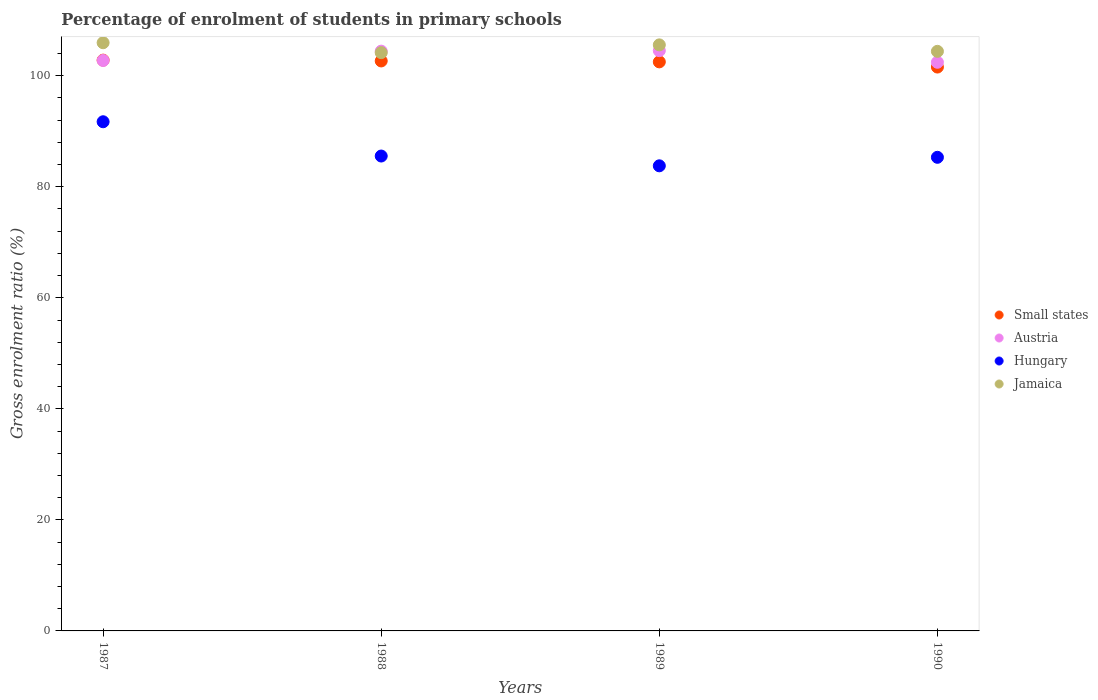How many different coloured dotlines are there?
Provide a succinct answer. 4. What is the percentage of students enrolled in primary schools in Small states in 1988?
Your answer should be compact. 102.66. Across all years, what is the maximum percentage of students enrolled in primary schools in Small states?
Your answer should be very brief. 102.81. Across all years, what is the minimum percentage of students enrolled in primary schools in Hungary?
Provide a succinct answer. 83.77. In which year was the percentage of students enrolled in primary schools in Jamaica maximum?
Your answer should be compact. 1987. In which year was the percentage of students enrolled in primary schools in Hungary minimum?
Provide a short and direct response. 1989. What is the total percentage of students enrolled in primary schools in Austria in the graph?
Provide a short and direct response. 414.12. What is the difference between the percentage of students enrolled in primary schools in Hungary in 1987 and that in 1988?
Your answer should be very brief. 6.17. What is the difference between the percentage of students enrolled in primary schools in Jamaica in 1989 and the percentage of students enrolled in primary schools in Austria in 1990?
Provide a short and direct response. 3.13. What is the average percentage of students enrolled in primary schools in Austria per year?
Ensure brevity in your answer.  103.53. In the year 1988, what is the difference between the percentage of students enrolled in primary schools in Small states and percentage of students enrolled in primary schools in Jamaica?
Ensure brevity in your answer.  -1.5. What is the ratio of the percentage of students enrolled in primary schools in Austria in 1989 to that in 1990?
Your answer should be very brief. 1.02. Is the difference between the percentage of students enrolled in primary schools in Small states in 1988 and 1989 greater than the difference between the percentage of students enrolled in primary schools in Jamaica in 1988 and 1989?
Offer a very short reply. Yes. What is the difference between the highest and the second highest percentage of students enrolled in primary schools in Small states?
Give a very brief answer. 0.15. What is the difference between the highest and the lowest percentage of students enrolled in primary schools in Hungary?
Keep it short and to the point. 7.94. In how many years, is the percentage of students enrolled in primary schools in Hungary greater than the average percentage of students enrolled in primary schools in Hungary taken over all years?
Offer a terse response. 1. Is the sum of the percentage of students enrolled in primary schools in Jamaica in 1987 and 1989 greater than the maximum percentage of students enrolled in primary schools in Hungary across all years?
Your answer should be very brief. Yes. Is it the case that in every year, the sum of the percentage of students enrolled in primary schools in Austria and percentage of students enrolled in primary schools in Jamaica  is greater than the sum of percentage of students enrolled in primary schools in Small states and percentage of students enrolled in primary schools in Hungary?
Your response must be concise. No. Is it the case that in every year, the sum of the percentage of students enrolled in primary schools in Hungary and percentage of students enrolled in primary schools in Austria  is greater than the percentage of students enrolled in primary schools in Small states?
Provide a succinct answer. Yes. Is the percentage of students enrolled in primary schools in Jamaica strictly less than the percentage of students enrolled in primary schools in Small states over the years?
Provide a succinct answer. No. How many dotlines are there?
Provide a short and direct response. 4. How many years are there in the graph?
Provide a succinct answer. 4. What is the difference between two consecutive major ticks on the Y-axis?
Give a very brief answer. 20. Does the graph contain grids?
Your response must be concise. No. Where does the legend appear in the graph?
Your answer should be very brief. Center right. What is the title of the graph?
Your answer should be very brief. Percentage of enrolment of students in primary schools. Does "Sudan" appear as one of the legend labels in the graph?
Keep it short and to the point. No. What is the Gross enrolment ratio (%) in Small states in 1987?
Your answer should be compact. 102.81. What is the Gross enrolment ratio (%) in Austria in 1987?
Your answer should be compact. 102.75. What is the Gross enrolment ratio (%) in Hungary in 1987?
Make the answer very short. 91.71. What is the Gross enrolment ratio (%) of Jamaica in 1987?
Your response must be concise. 105.94. What is the Gross enrolment ratio (%) in Small states in 1988?
Offer a terse response. 102.66. What is the Gross enrolment ratio (%) in Austria in 1988?
Your answer should be compact. 104.43. What is the Gross enrolment ratio (%) of Hungary in 1988?
Provide a succinct answer. 85.54. What is the Gross enrolment ratio (%) in Jamaica in 1988?
Keep it short and to the point. 104.16. What is the Gross enrolment ratio (%) in Small states in 1989?
Ensure brevity in your answer.  102.5. What is the Gross enrolment ratio (%) in Austria in 1989?
Offer a terse response. 104.52. What is the Gross enrolment ratio (%) of Hungary in 1989?
Offer a terse response. 83.77. What is the Gross enrolment ratio (%) in Jamaica in 1989?
Keep it short and to the point. 105.56. What is the Gross enrolment ratio (%) of Small states in 1990?
Offer a terse response. 101.56. What is the Gross enrolment ratio (%) of Austria in 1990?
Give a very brief answer. 102.42. What is the Gross enrolment ratio (%) in Hungary in 1990?
Make the answer very short. 85.31. What is the Gross enrolment ratio (%) of Jamaica in 1990?
Keep it short and to the point. 104.39. Across all years, what is the maximum Gross enrolment ratio (%) of Small states?
Provide a short and direct response. 102.81. Across all years, what is the maximum Gross enrolment ratio (%) of Austria?
Provide a succinct answer. 104.52. Across all years, what is the maximum Gross enrolment ratio (%) in Hungary?
Ensure brevity in your answer.  91.71. Across all years, what is the maximum Gross enrolment ratio (%) of Jamaica?
Keep it short and to the point. 105.94. Across all years, what is the minimum Gross enrolment ratio (%) of Small states?
Provide a short and direct response. 101.56. Across all years, what is the minimum Gross enrolment ratio (%) of Austria?
Your response must be concise. 102.42. Across all years, what is the minimum Gross enrolment ratio (%) in Hungary?
Provide a short and direct response. 83.77. Across all years, what is the minimum Gross enrolment ratio (%) of Jamaica?
Provide a succinct answer. 104.16. What is the total Gross enrolment ratio (%) of Small states in the graph?
Make the answer very short. 409.53. What is the total Gross enrolment ratio (%) in Austria in the graph?
Your response must be concise. 414.12. What is the total Gross enrolment ratio (%) of Hungary in the graph?
Give a very brief answer. 346.33. What is the total Gross enrolment ratio (%) in Jamaica in the graph?
Provide a short and direct response. 420.05. What is the difference between the Gross enrolment ratio (%) of Small states in 1987 and that in 1988?
Provide a succinct answer. 0.15. What is the difference between the Gross enrolment ratio (%) in Austria in 1987 and that in 1988?
Your response must be concise. -1.68. What is the difference between the Gross enrolment ratio (%) of Hungary in 1987 and that in 1988?
Ensure brevity in your answer.  6.17. What is the difference between the Gross enrolment ratio (%) in Jamaica in 1987 and that in 1988?
Give a very brief answer. 1.79. What is the difference between the Gross enrolment ratio (%) in Small states in 1987 and that in 1989?
Your response must be concise. 0.31. What is the difference between the Gross enrolment ratio (%) of Austria in 1987 and that in 1989?
Ensure brevity in your answer.  -1.77. What is the difference between the Gross enrolment ratio (%) of Hungary in 1987 and that in 1989?
Offer a terse response. 7.94. What is the difference between the Gross enrolment ratio (%) of Jamaica in 1987 and that in 1989?
Your response must be concise. 0.39. What is the difference between the Gross enrolment ratio (%) of Small states in 1987 and that in 1990?
Offer a very short reply. 1.25. What is the difference between the Gross enrolment ratio (%) of Austria in 1987 and that in 1990?
Ensure brevity in your answer.  0.32. What is the difference between the Gross enrolment ratio (%) in Hungary in 1987 and that in 1990?
Offer a very short reply. 6.4. What is the difference between the Gross enrolment ratio (%) in Jamaica in 1987 and that in 1990?
Provide a succinct answer. 1.55. What is the difference between the Gross enrolment ratio (%) in Small states in 1988 and that in 1989?
Ensure brevity in your answer.  0.17. What is the difference between the Gross enrolment ratio (%) in Austria in 1988 and that in 1989?
Keep it short and to the point. -0.09. What is the difference between the Gross enrolment ratio (%) in Hungary in 1988 and that in 1989?
Provide a succinct answer. 1.76. What is the difference between the Gross enrolment ratio (%) of Small states in 1988 and that in 1990?
Provide a succinct answer. 1.1. What is the difference between the Gross enrolment ratio (%) in Austria in 1988 and that in 1990?
Give a very brief answer. 2.01. What is the difference between the Gross enrolment ratio (%) of Hungary in 1988 and that in 1990?
Offer a terse response. 0.23. What is the difference between the Gross enrolment ratio (%) of Jamaica in 1988 and that in 1990?
Your answer should be very brief. -0.24. What is the difference between the Gross enrolment ratio (%) in Small states in 1989 and that in 1990?
Keep it short and to the point. 0.93. What is the difference between the Gross enrolment ratio (%) of Austria in 1989 and that in 1990?
Your answer should be very brief. 2.09. What is the difference between the Gross enrolment ratio (%) in Hungary in 1989 and that in 1990?
Give a very brief answer. -1.53. What is the difference between the Gross enrolment ratio (%) of Jamaica in 1989 and that in 1990?
Your answer should be very brief. 1.16. What is the difference between the Gross enrolment ratio (%) in Small states in 1987 and the Gross enrolment ratio (%) in Austria in 1988?
Ensure brevity in your answer.  -1.62. What is the difference between the Gross enrolment ratio (%) in Small states in 1987 and the Gross enrolment ratio (%) in Hungary in 1988?
Ensure brevity in your answer.  17.27. What is the difference between the Gross enrolment ratio (%) of Small states in 1987 and the Gross enrolment ratio (%) of Jamaica in 1988?
Your response must be concise. -1.35. What is the difference between the Gross enrolment ratio (%) in Austria in 1987 and the Gross enrolment ratio (%) in Hungary in 1988?
Make the answer very short. 17.21. What is the difference between the Gross enrolment ratio (%) in Austria in 1987 and the Gross enrolment ratio (%) in Jamaica in 1988?
Your answer should be compact. -1.41. What is the difference between the Gross enrolment ratio (%) in Hungary in 1987 and the Gross enrolment ratio (%) in Jamaica in 1988?
Make the answer very short. -12.45. What is the difference between the Gross enrolment ratio (%) in Small states in 1987 and the Gross enrolment ratio (%) in Austria in 1989?
Offer a very short reply. -1.71. What is the difference between the Gross enrolment ratio (%) of Small states in 1987 and the Gross enrolment ratio (%) of Hungary in 1989?
Your response must be concise. 19.04. What is the difference between the Gross enrolment ratio (%) in Small states in 1987 and the Gross enrolment ratio (%) in Jamaica in 1989?
Your answer should be very brief. -2.75. What is the difference between the Gross enrolment ratio (%) in Austria in 1987 and the Gross enrolment ratio (%) in Hungary in 1989?
Ensure brevity in your answer.  18.97. What is the difference between the Gross enrolment ratio (%) in Austria in 1987 and the Gross enrolment ratio (%) in Jamaica in 1989?
Provide a succinct answer. -2.81. What is the difference between the Gross enrolment ratio (%) in Hungary in 1987 and the Gross enrolment ratio (%) in Jamaica in 1989?
Provide a short and direct response. -13.85. What is the difference between the Gross enrolment ratio (%) in Small states in 1987 and the Gross enrolment ratio (%) in Austria in 1990?
Your answer should be very brief. 0.39. What is the difference between the Gross enrolment ratio (%) of Small states in 1987 and the Gross enrolment ratio (%) of Hungary in 1990?
Offer a terse response. 17.5. What is the difference between the Gross enrolment ratio (%) in Small states in 1987 and the Gross enrolment ratio (%) in Jamaica in 1990?
Provide a short and direct response. -1.58. What is the difference between the Gross enrolment ratio (%) in Austria in 1987 and the Gross enrolment ratio (%) in Hungary in 1990?
Your answer should be compact. 17.44. What is the difference between the Gross enrolment ratio (%) in Austria in 1987 and the Gross enrolment ratio (%) in Jamaica in 1990?
Make the answer very short. -1.65. What is the difference between the Gross enrolment ratio (%) of Hungary in 1987 and the Gross enrolment ratio (%) of Jamaica in 1990?
Give a very brief answer. -12.68. What is the difference between the Gross enrolment ratio (%) of Small states in 1988 and the Gross enrolment ratio (%) of Austria in 1989?
Ensure brevity in your answer.  -1.85. What is the difference between the Gross enrolment ratio (%) in Small states in 1988 and the Gross enrolment ratio (%) in Hungary in 1989?
Ensure brevity in your answer.  18.89. What is the difference between the Gross enrolment ratio (%) in Small states in 1988 and the Gross enrolment ratio (%) in Jamaica in 1989?
Ensure brevity in your answer.  -2.9. What is the difference between the Gross enrolment ratio (%) in Austria in 1988 and the Gross enrolment ratio (%) in Hungary in 1989?
Your answer should be very brief. 20.66. What is the difference between the Gross enrolment ratio (%) in Austria in 1988 and the Gross enrolment ratio (%) in Jamaica in 1989?
Ensure brevity in your answer.  -1.13. What is the difference between the Gross enrolment ratio (%) in Hungary in 1988 and the Gross enrolment ratio (%) in Jamaica in 1989?
Make the answer very short. -20.02. What is the difference between the Gross enrolment ratio (%) of Small states in 1988 and the Gross enrolment ratio (%) of Austria in 1990?
Provide a succinct answer. 0.24. What is the difference between the Gross enrolment ratio (%) in Small states in 1988 and the Gross enrolment ratio (%) in Hungary in 1990?
Keep it short and to the point. 17.36. What is the difference between the Gross enrolment ratio (%) in Small states in 1988 and the Gross enrolment ratio (%) in Jamaica in 1990?
Give a very brief answer. -1.73. What is the difference between the Gross enrolment ratio (%) in Austria in 1988 and the Gross enrolment ratio (%) in Hungary in 1990?
Offer a very short reply. 19.12. What is the difference between the Gross enrolment ratio (%) in Austria in 1988 and the Gross enrolment ratio (%) in Jamaica in 1990?
Offer a very short reply. 0.04. What is the difference between the Gross enrolment ratio (%) in Hungary in 1988 and the Gross enrolment ratio (%) in Jamaica in 1990?
Provide a short and direct response. -18.86. What is the difference between the Gross enrolment ratio (%) of Small states in 1989 and the Gross enrolment ratio (%) of Austria in 1990?
Your answer should be compact. 0.07. What is the difference between the Gross enrolment ratio (%) of Small states in 1989 and the Gross enrolment ratio (%) of Hungary in 1990?
Your answer should be compact. 17.19. What is the difference between the Gross enrolment ratio (%) of Small states in 1989 and the Gross enrolment ratio (%) of Jamaica in 1990?
Your answer should be very brief. -1.9. What is the difference between the Gross enrolment ratio (%) in Austria in 1989 and the Gross enrolment ratio (%) in Hungary in 1990?
Provide a succinct answer. 19.21. What is the difference between the Gross enrolment ratio (%) in Austria in 1989 and the Gross enrolment ratio (%) in Jamaica in 1990?
Provide a succinct answer. 0.12. What is the difference between the Gross enrolment ratio (%) in Hungary in 1989 and the Gross enrolment ratio (%) in Jamaica in 1990?
Offer a very short reply. -20.62. What is the average Gross enrolment ratio (%) in Small states per year?
Your response must be concise. 102.38. What is the average Gross enrolment ratio (%) of Austria per year?
Offer a very short reply. 103.53. What is the average Gross enrolment ratio (%) of Hungary per year?
Your response must be concise. 86.58. What is the average Gross enrolment ratio (%) of Jamaica per year?
Provide a short and direct response. 105.01. In the year 1987, what is the difference between the Gross enrolment ratio (%) of Small states and Gross enrolment ratio (%) of Austria?
Provide a short and direct response. 0.06. In the year 1987, what is the difference between the Gross enrolment ratio (%) of Small states and Gross enrolment ratio (%) of Hungary?
Offer a very short reply. 11.1. In the year 1987, what is the difference between the Gross enrolment ratio (%) of Small states and Gross enrolment ratio (%) of Jamaica?
Make the answer very short. -3.13. In the year 1987, what is the difference between the Gross enrolment ratio (%) in Austria and Gross enrolment ratio (%) in Hungary?
Offer a terse response. 11.04. In the year 1987, what is the difference between the Gross enrolment ratio (%) in Austria and Gross enrolment ratio (%) in Jamaica?
Provide a succinct answer. -3.2. In the year 1987, what is the difference between the Gross enrolment ratio (%) in Hungary and Gross enrolment ratio (%) in Jamaica?
Provide a succinct answer. -14.23. In the year 1988, what is the difference between the Gross enrolment ratio (%) of Small states and Gross enrolment ratio (%) of Austria?
Your answer should be compact. -1.77. In the year 1988, what is the difference between the Gross enrolment ratio (%) in Small states and Gross enrolment ratio (%) in Hungary?
Provide a succinct answer. 17.13. In the year 1988, what is the difference between the Gross enrolment ratio (%) of Small states and Gross enrolment ratio (%) of Jamaica?
Your answer should be compact. -1.5. In the year 1988, what is the difference between the Gross enrolment ratio (%) in Austria and Gross enrolment ratio (%) in Hungary?
Provide a succinct answer. 18.89. In the year 1988, what is the difference between the Gross enrolment ratio (%) of Austria and Gross enrolment ratio (%) of Jamaica?
Provide a short and direct response. 0.27. In the year 1988, what is the difference between the Gross enrolment ratio (%) of Hungary and Gross enrolment ratio (%) of Jamaica?
Give a very brief answer. -18.62. In the year 1989, what is the difference between the Gross enrolment ratio (%) of Small states and Gross enrolment ratio (%) of Austria?
Keep it short and to the point. -2.02. In the year 1989, what is the difference between the Gross enrolment ratio (%) in Small states and Gross enrolment ratio (%) in Hungary?
Make the answer very short. 18.72. In the year 1989, what is the difference between the Gross enrolment ratio (%) in Small states and Gross enrolment ratio (%) in Jamaica?
Provide a short and direct response. -3.06. In the year 1989, what is the difference between the Gross enrolment ratio (%) in Austria and Gross enrolment ratio (%) in Hungary?
Your answer should be very brief. 20.74. In the year 1989, what is the difference between the Gross enrolment ratio (%) of Austria and Gross enrolment ratio (%) of Jamaica?
Give a very brief answer. -1.04. In the year 1989, what is the difference between the Gross enrolment ratio (%) of Hungary and Gross enrolment ratio (%) of Jamaica?
Make the answer very short. -21.78. In the year 1990, what is the difference between the Gross enrolment ratio (%) in Small states and Gross enrolment ratio (%) in Austria?
Your answer should be compact. -0.86. In the year 1990, what is the difference between the Gross enrolment ratio (%) of Small states and Gross enrolment ratio (%) of Hungary?
Offer a terse response. 16.26. In the year 1990, what is the difference between the Gross enrolment ratio (%) in Small states and Gross enrolment ratio (%) in Jamaica?
Your answer should be compact. -2.83. In the year 1990, what is the difference between the Gross enrolment ratio (%) in Austria and Gross enrolment ratio (%) in Hungary?
Your answer should be compact. 17.12. In the year 1990, what is the difference between the Gross enrolment ratio (%) in Austria and Gross enrolment ratio (%) in Jamaica?
Your answer should be compact. -1.97. In the year 1990, what is the difference between the Gross enrolment ratio (%) of Hungary and Gross enrolment ratio (%) of Jamaica?
Give a very brief answer. -19.09. What is the ratio of the Gross enrolment ratio (%) of Small states in 1987 to that in 1988?
Provide a short and direct response. 1. What is the ratio of the Gross enrolment ratio (%) of Austria in 1987 to that in 1988?
Your answer should be compact. 0.98. What is the ratio of the Gross enrolment ratio (%) in Hungary in 1987 to that in 1988?
Your answer should be very brief. 1.07. What is the ratio of the Gross enrolment ratio (%) of Jamaica in 1987 to that in 1988?
Your answer should be compact. 1.02. What is the ratio of the Gross enrolment ratio (%) in Austria in 1987 to that in 1989?
Offer a terse response. 0.98. What is the ratio of the Gross enrolment ratio (%) of Hungary in 1987 to that in 1989?
Offer a very short reply. 1.09. What is the ratio of the Gross enrolment ratio (%) in Small states in 1987 to that in 1990?
Provide a short and direct response. 1.01. What is the ratio of the Gross enrolment ratio (%) in Austria in 1987 to that in 1990?
Ensure brevity in your answer.  1. What is the ratio of the Gross enrolment ratio (%) of Hungary in 1987 to that in 1990?
Offer a very short reply. 1.08. What is the ratio of the Gross enrolment ratio (%) in Jamaica in 1987 to that in 1990?
Give a very brief answer. 1.01. What is the ratio of the Gross enrolment ratio (%) in Small states in 1988 to that in 1989?
Your response must be concise. 1. What is the ratio of the Gross enrolment ratio (%) of Jamaica in 1988 to that in 1989?
Keep it short and to the point. 0.99. What is the ratio of the Gross enrolment ratio (%) of Small states in 1988 to that in 1990?
Your answer should be compact. 1.01. What is the ratio of the Gross enrolment ratio (%) of Austria in 1988 to that in 1990?
Offer a very short reply. 1.02. What is the ratio of the Gross enrolment ratio (%) in Hungary in 1988 to that in 1990?
Offer a terse response. 1. What is the ratio of the Gross enrolment ratio (%) of Jamaica in 1988 to that in 1990?
Keep it short and to the point. 1. What is the ratio of the Gross enrolment ratio (%) of Small states in 1989 to that in 1990?
Keep it short and to the point. 1.01. What is the ratio of the Gross enrolment ratio (%) in Austria in 1989 to that in 1990?
Offer a terse response. 1.02. What is the ratio of the Gross enrolment ratio (%) of Jamaica in 1989 to that in 1990?
Your answer should be compact. 1.01. What is the difference between the highest and the second highest Gross enrolment ratio (%) of Small states?
Offer a terse response. 0.15. What is the difference between the highest and the second highest Gross enrolment ratio (%) in Austria?
Keep it short and to the point. 0.09. What is the difference between the highest and the second highest Gross enrolment ratio (%) in Hungary?
Your response must be concise. 6.17. What is the difference between the highest and the second highest Gross enrolment ratio (%) of Jamaica?
Provide a short and direct response. 0.39. What is the difference between the highest and the lowest Gross enrolment ratio (%) in Small states?
Your answer should be very brief. 1.25. What is the difference between the highest and the lowest Gross enrolment ratio (%) of Austria?
Give a very brief answer. 2.09. What is the difference between the highest and the lowest Gross enrolment ratio (%) in Hungary?
Offer a terse response. 7.94. What is the difference between the highest and the lowest Gross enrolment ratio (%) of Jamaica?
Offer a very short reply. 1.79. 